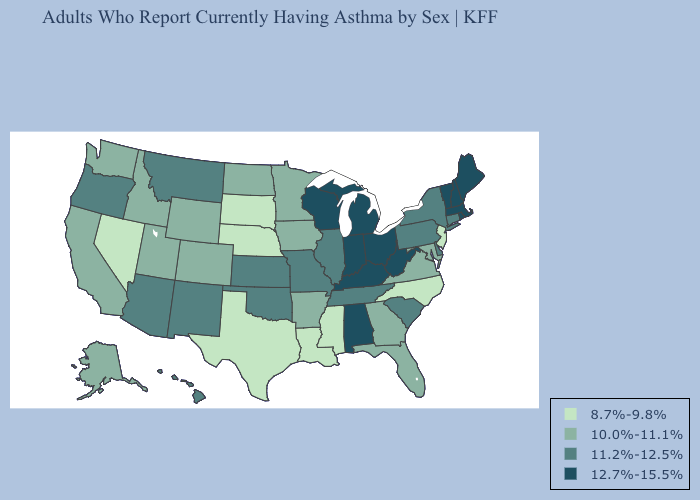What is the value of Michigan?
Quick response, please. 12.7%-15.5%. What is the lowest value in the Northeast?
Write a very short answer. 8.7%-9.8%. Does Louisiana have a lower value than Massachusetts?
Write a very short answer. Yes. Name the states that have a value in the range 10.0%-11.1%?
Keep it brief. Alaska, Arkansas, California, Colorado, Florida, Georgia, Idaho, Iowa, Maryland, Minnesota, North Dakota, Utah, Virginia, Washington, Wyoming. Among the states that border Kansas , does Nebraska have the highest value?
Be succinct. No. Does the first symbol in the legend represent the smallest category?
Keep it brief. Yes. Does South Dakota have a higher value than Illinois?
Give a very brief answer. No. Does Massachusetts have the highest value in the USA?
Be succinct. Yes. What is the lowest value in the USA?
Write a very short answer. 8.7%-9.8%. Name the states that have a value in the range 8.7%-9.8%?
Write a very short answer. Louisiana, Mississippi, Nebraska, Nevada, New Jersey, North Carolina, South Dakota, Texas. Does the first symbol in the legend represent the smallest category?
Quick response, please. Yes. What is the value of North Carolina?
Give a very brief answer. 8.7%-9.8%. What is the lowest value in the USA?
Short answer required. 8.7%-9.8%. What is the highest value in the USA?
Answer briefly. 12.7%-15.5%. Name the states that have a value in the range 8.7%-9.8%?
Short answer required. Louisiana, Mississippi, Nebraska, Nevada, New Jersey, North Carolina, South Dakota, Texas. 